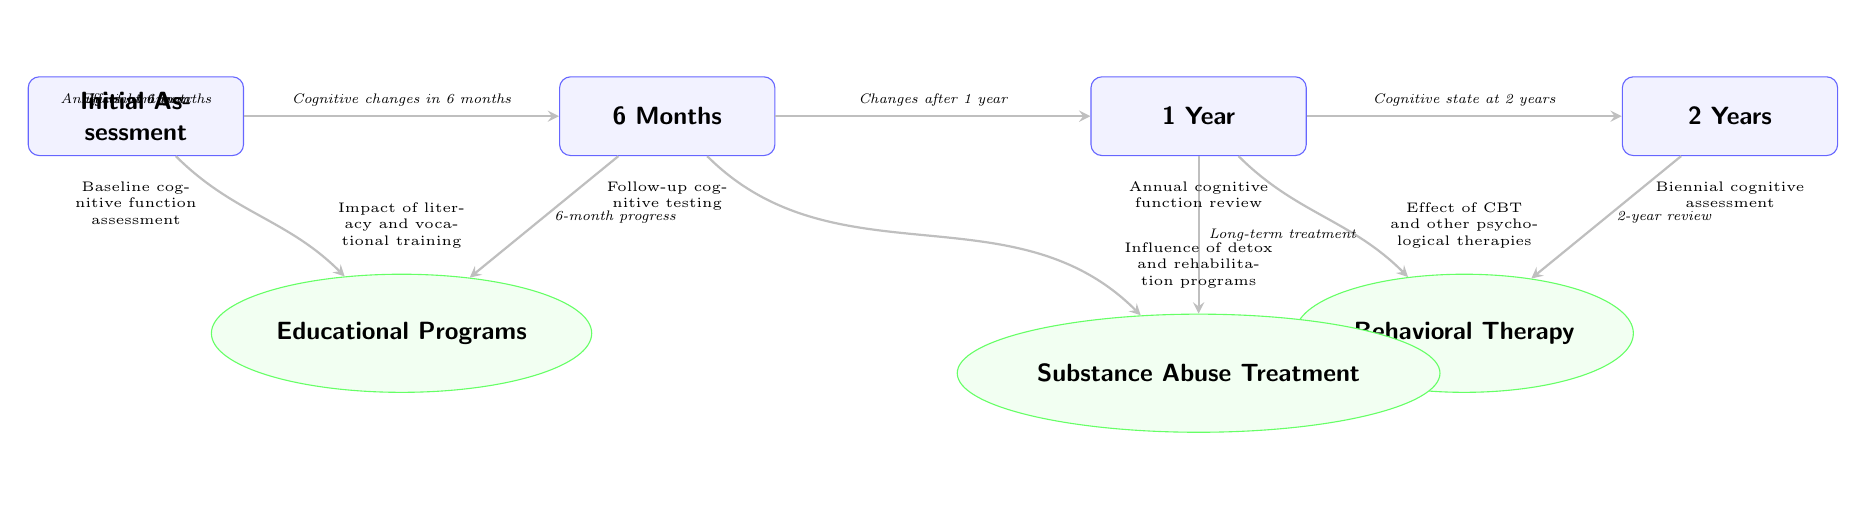What is the first assessment in the timeline? The diagram shows the first assessment node as "Initial Assessment," which is the starting point for the timeline of neurological assessments.
Answer: Initial Assessment How many assessments are included in the timeline? There are four assessment nodes in the timeline: Initial Assessment, 6 Months, 1 Year, and 2 Years, making a total of four assessments.
Answer: 4 What program is associated with the 6-month assessment? The diagram indicates an arrow pointing from the 6-month node to the Substance Abuse Treatment program node, showing this program's relation to the 6-month assessment.
Answer: Substance Abuse Treatment Which program follows the 1 Year assessment? The arrow from the 1 Year node points downward to the Behavioral Therapy program, indicating it is the program that follows this assessment.
Answer: Behavioral Therapy What cognitive improvement is indicated after 2 years? The diagram states that the cognitive state at 2 years is reviewed through an arrow leading to the Behavioral Therapy program, representing ongoing assessments and possibly improvements at this stage.
Answer: Cognitive state at 2 years What shows the impact of educational programs? The diagram illustrates the impact of educational programs stemming from the Initial Assessment with an arrow leading downward, signifying its role in the timeline.
Answer: Initial impact How long after the Initial Assessment is the first program's analysis conducted? Following the arrows from the Initial Assessment node, the first program's analysis occurs at the 6-month mark, indicating a half-year timeline before analysis.
Answer: 6 months What type of therapy is represented at the 1 Year assessment? The diagram shows that Behavioral Therapy is emphasized in relation to the 1 Year assessment, signifying the therapeutic approach taken at that stage.
Answer: Behavioral Therapy What are the two key programs that affect cognitive changes at 6 months? Analyzing the diagram, the two key programs affecting cognitive changes at the 6-month mark are Educational Programs and Substance Abuse Treatment, both connected with arrows to the 6-month assessment.
Answer: Educational Programs and Substance Abuse Treatment What is the relationship between the 2 Year assessment and Behavioral Therapy? The diagram indicates a review of the cognitive state at the 2 Year assessment, which is connected to Behavioral Therapy, showing a relationship indicating continuous assessment and potential improvements through the therapy.
Answer: Continuous assessment and potential improvements 